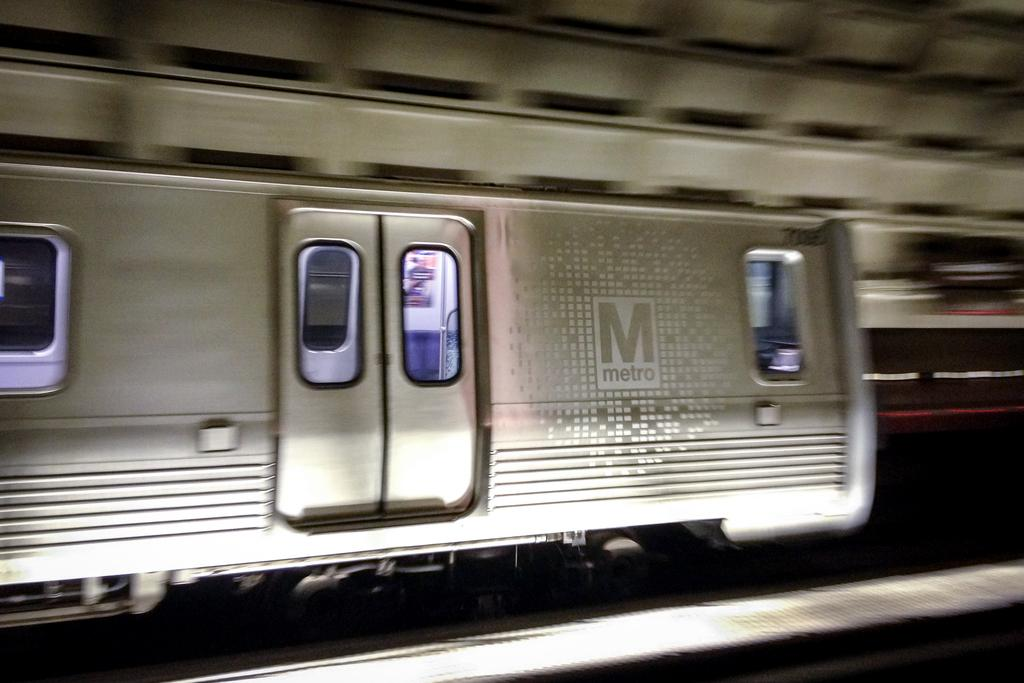<image>
Present a compact description of the photo's key features. a subway that says 'metro' on the wall of it outside 